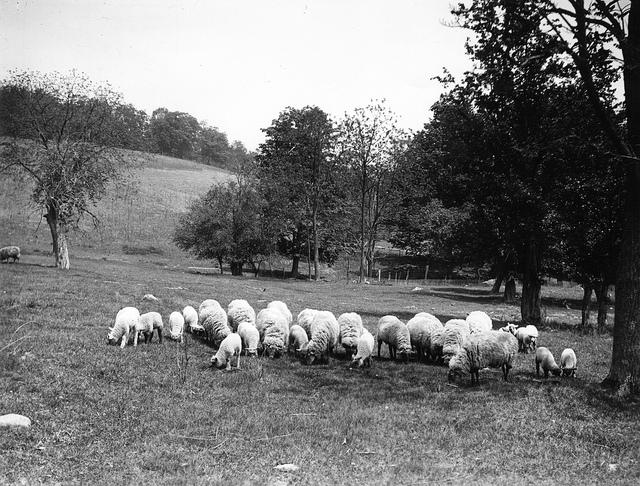Is this picture black and white or color?
Keep it brief. Black and white. How many animals are in the picture?
Keep it brief. 23. Which animal is this?
Keep it brief. Sheep. What kind of animals are shown?
Quick response, please. Sheep. How many sheep are in the picture?
Keep it brief. 15. Are there more than 10 animals?
Concise answer only. Yes. Are the animals afraid?
Short answer required. No. 